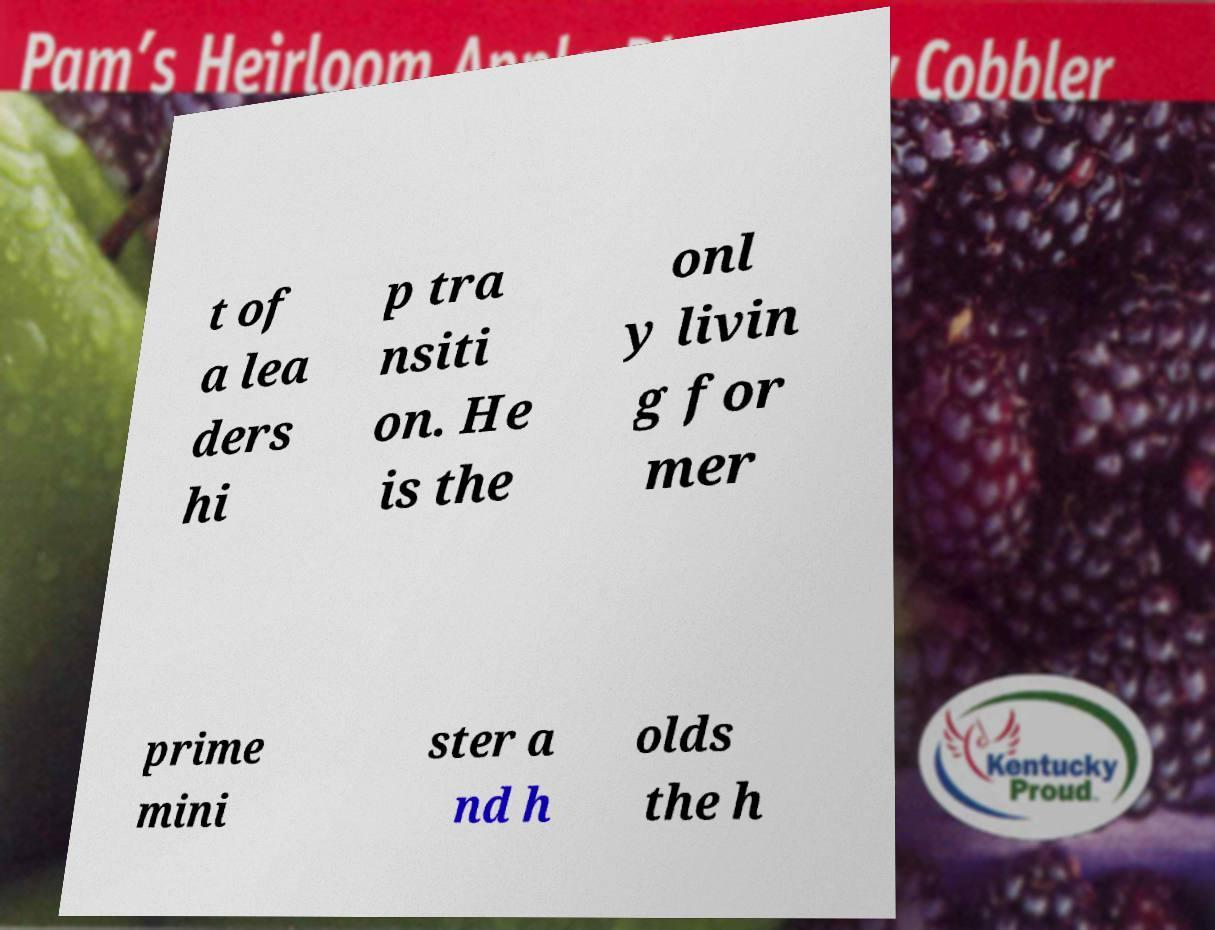For documentation purposes, I need the text within this image transcribed. Could you provide that? t of a lea ders hi p tra nsiti on. He is the onl y livin g for mer prime mini ster a nd h olds the h 